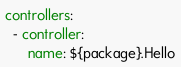Convert code to text. <code><loc_0><loc_0><loc_500><loc_500><_YAML_>controllers:
  - controller:
      name: ${package}.Hello
</code> 